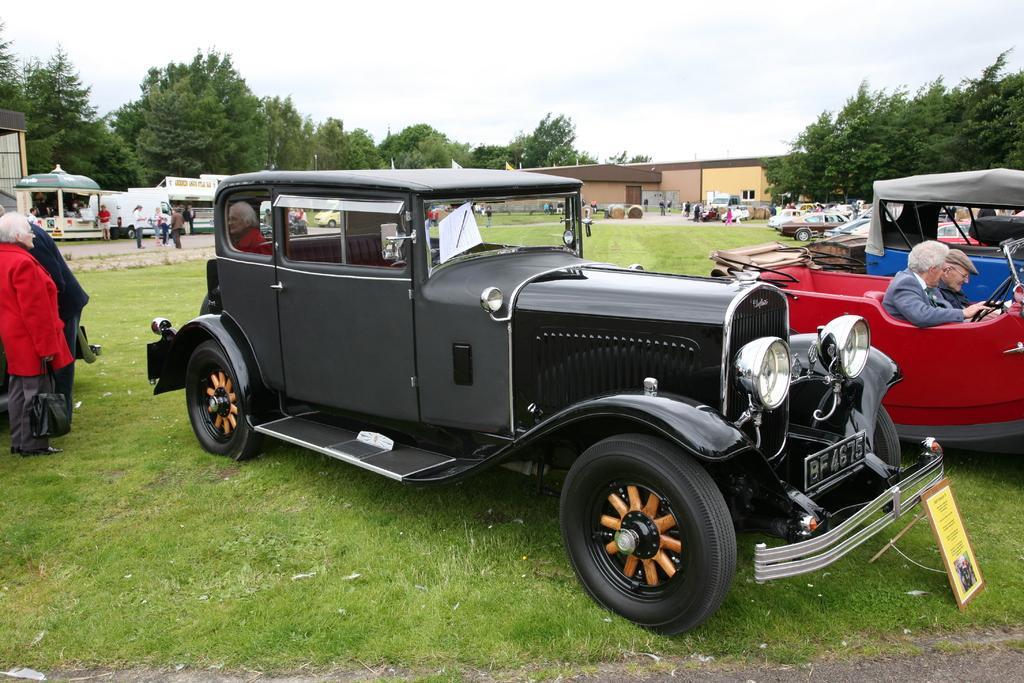Could you give a brief overview of what you see in this image? In this image in the foreground there are some vehicles and some persons are sitting on a vehicles, in the background there are some houses, stores, tents and some people are walking. And also there are some vehicles, plants. On the left side there are two persons who are standing, at the bottom there is grass and in the background there are some trees. On the top of the image there is sky. 